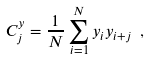Convert formula to latex. <formula><loc_0><loc_0><loc_500><loc_500>C _ { j } ^ { y } = \frac { 1 } { N } \sum _ { i = 1 } ^ { N } y _ { i } y _ { i + j } \ ,</formula> 